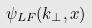<formula> <loc_0><loc_0><loc_500><loc_500>\psi _ { L F } ( k _ { \perp } , x )</formula> 